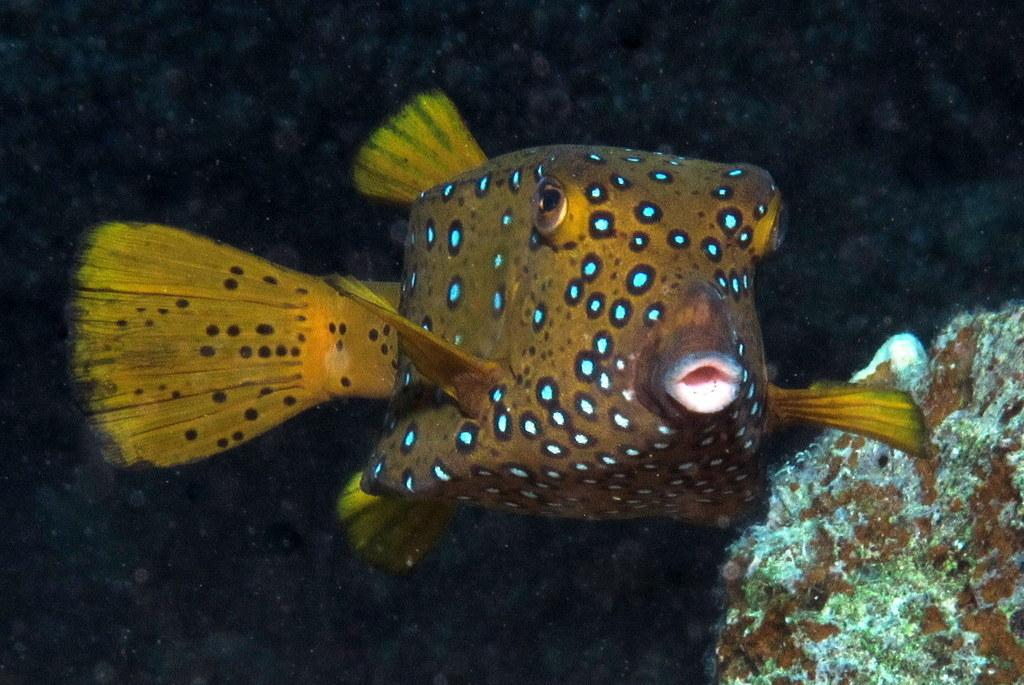What type of animal is depicted in the image? There is a yellow designed fish in the image. What is the fish doing in the image? The fish is swimming in the water. What can be seen on the right side of the image? There is a stone on the right side of the image. What is the size of the patch on the fish's fin in the image? There is no patch on the fish's fin in the image. 